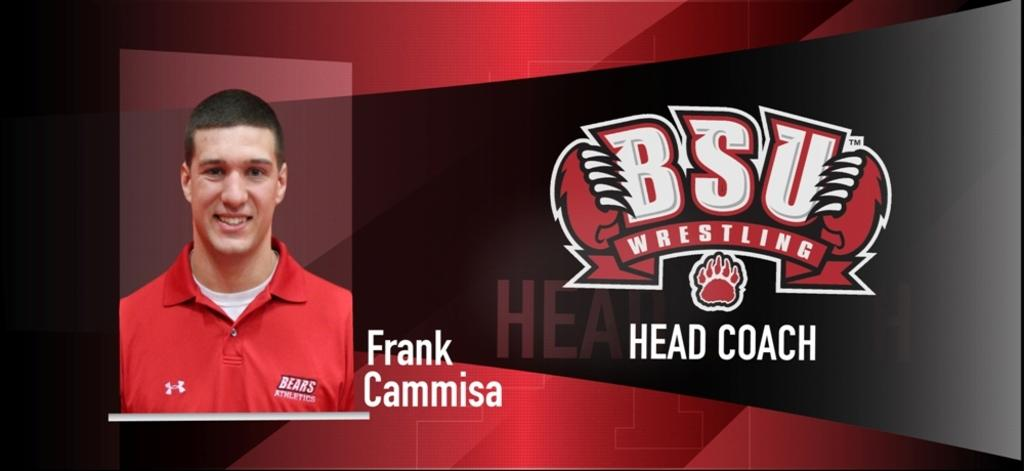Provide a one-sentence caption for the provided image. BSU Wrestling's head coach smiles in his headshot. 